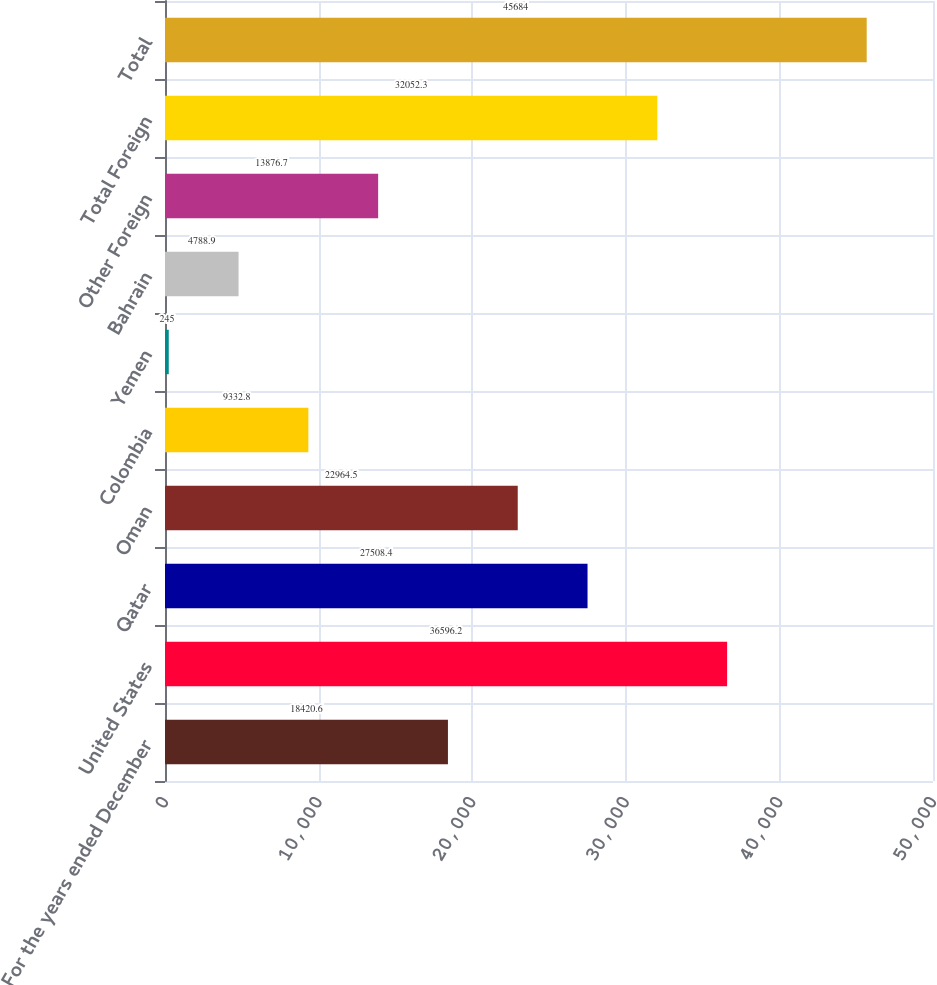Convert chart to OTSL. <chart><loc_0><loc_0><loc_500><loc_500><bar_chart><fcel>For the years ended December<fcel>United States<fcel>Qatar<fcel>Oman<fcel>Colombia<fcel>Yemen<fcel>Bahrain<fcel>Other Foreign<fcel>Total Foreign<fcel>Total<nl><fcel>18420.6<fcel>36596.2<fcel>27508.4<fcel>22964.5<fcel>9332.8<fcel>245<fcel>4788.9<fcel>13876.7<fcel>32052.3<fcel>45684<nl></chart> 